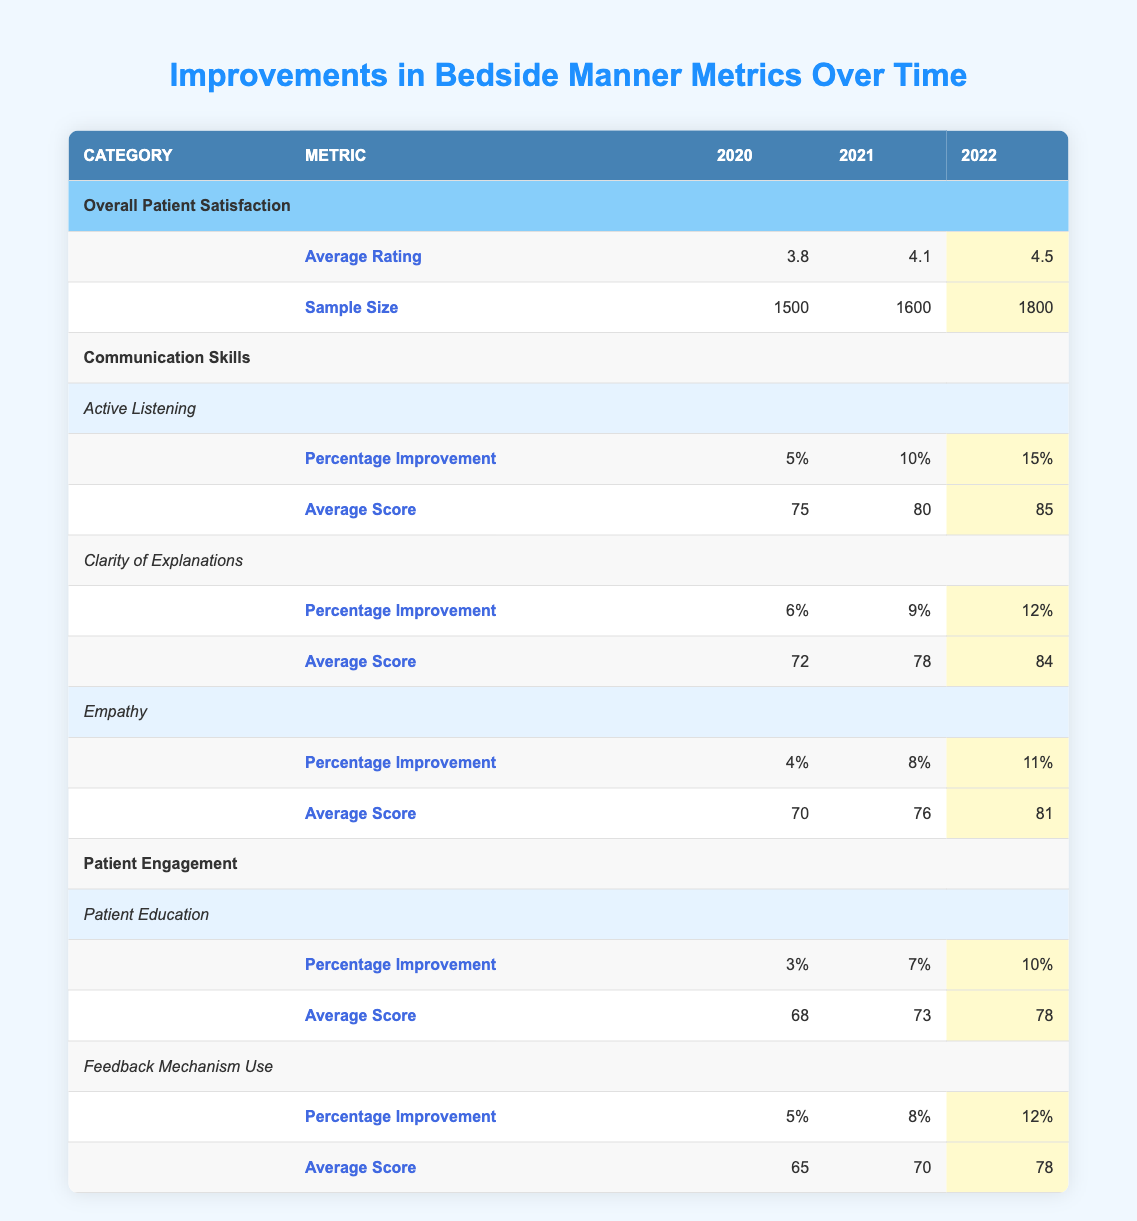What was the average rating for overall patient satisfaction in 2021? The table shows the average rating for overall patient satisfaction in 2021 is listed under "Average Rating" in the corresponding year, which is 4.1.
Answer: 4.1 What is the percentage improvement in Active Listening from 2020 to 2022? To find the percentage improvement, I look at the values for Active Listening in 2020 and 2022, which are 5% and 15%, respectively. The difference is 15% - 5% = 10%.
Answer: 10% How many sample sizes were there in total across the years for Overall Patient Satisfaction? The sample sizes for the years 2020, 2021, and 2022 are 1500, 1600, and 1800, respectively. Adding these gives 1500 + 1600 + 1800 = 4900.
Answer: 4900 Did the percentage improvement in Empathy increase every year? Looking at the percentage improvements in Empathy over the years, they are 4% in 2020, 8% in 2021, and 11% in 2022. Each year shows an increase, confirming that the improvement went up consistently.
Answer: Yes What was the average score for Feedback Mechanism Use in 2022? The average score for Feedback Mechanism Use in 2022 is found in the table under "Average Score", specifically listed for that year, which is 78.
Answer: 78 What is the difference in average scores for Clarity of Explanations between 2020 and 2022? For Clarity of Explanations, the average scores for 2020 and 2022 are 72 and 84, respectively. The difference is calculated as 84 - 72 = 12.
Answer: 12 Was there any year in which the average rating for Overall Patient Satisfaction was below 4.0? The average ratings for each year are 3.8 in 2020, 4.1 in 2021, and 4.5 in 2022. The rating of 3.8 in 2020 is below 4.0, confirming that at least one year did have a rating below this threshold.
Answer: Yes What was the highest percentage improvement recorded for any metric over the years? Reviewing the percentage improvements listed in the table, the highest value is 15% for Active Listening in 2022, which is the maximum among all reported improvements.
Answer: 15% 